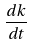Convert formula to latex. <formula><loc_0><loc_0><loc_500><loc_500>\frac { d k } { d t }</formula> 